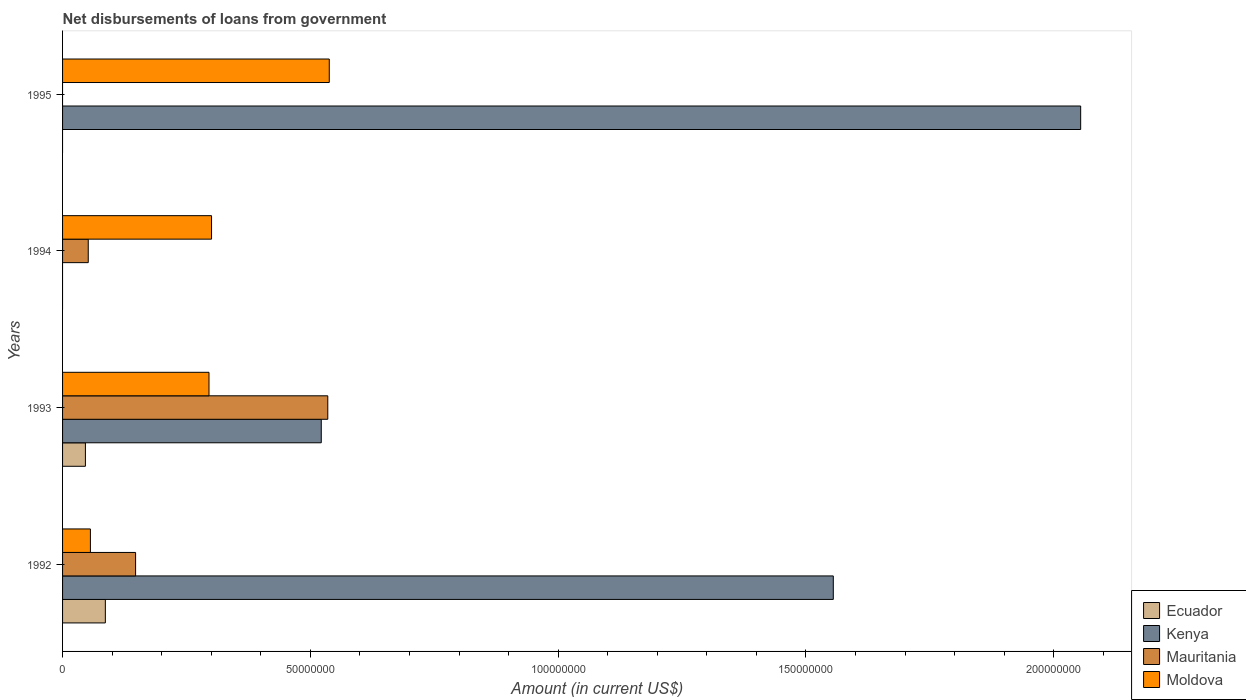Are the number of bars per tick equal to the number of legend labels?
Provide a succinct answer. No. Are the number of bars on each tick of the Y-axis equal?
Provide a succinct answer. No. What is the label of the 1st group of bars from the top?
Provide a succinct answer. 1995. What is the amount of loan disbursed from government in Kenya in 1995?
Give a very brief answer. 2.05e+08. Across all years, what is the maximum amount of loan disbursed from government in Kenya?
Provide a short and direct response. 2.05e+08. In which year was the amount of loan disbursed from government in Ecuador maximum?
Make the answer very short. 1992. What is the total amount of loan disbursed from government in Mauritania in the graph?
Offer a very short reply. 7.34e+07. What is the difference between the amount of loan disbursed from government in Moldova in 1994 and that in 1995?
Provide a short and direct response. -2.38e+07. What is the difference between the amount of loan disbursed from government in Kenya in 1993 and the amount of loan disbursed from government in Mauritania in 1994?
Provide a short and direct response. 4.70e+07. What is the average amount of loan disbursed from government in Kenya per year?
Keep it short and to the point. 1.03e+08. In the year 1993, what is the difference between the amount of loan disbursed from government in Moldova and amount of loan disbursed from government in Mauritania?
Give a very brief answer. -2.40e+07. In how many years, is the amount of loan disbursed from government in Moldova greater than 200000000 US$?
Make the answer very short. 0. What is the ratio of the amount of loan disbursed from government in Moldova in 1994 to that in 1995?
Offer a terse response. 0.56. Is the amount of loan disbursed from government in Kenya in 1993 less than that in 1995?
Make the answer very short. Yes. Is the difference between the amount of loan disbursed from government in Moldova in 1992 and 1994 greater than the difference between the amount of loan disbursed from government in Mauritania in 1992 and 1994?
Your answer should be very brief. No. What is the difference between the highest and the second highest amount of loan disbursed from government in Mauritania?
Make the answer very short. 3.88e+07. What is the difference between the highest and the lowest amount of loan disbursed from government in Moldova?
Provide a succinct answer. 4.82e+07. Is the sum of the amount of loan disbursed from government in Mauritania in 1992 and 1993 greater than the maximum amount of loan disbursed from government in Kenya across all years?
Your answer should be very brief. No. Are all the bars in the graph horizontal?
Offer a very short reply. Yes. How many years are there in the graph?
Give a very brief answer. 4. Are the values on the major ticks of X-axis written in scientific E-notation?
Keep it short and to the point. No. Does the graph contain grids?
Offer a terse response. No. How are the legend labels stacked?
Your response must be concise. Vertical. What is the title of the graph?
Provide a succinct answer. Net disbursements of loans from government. What is the label or title of the Y-axis?
Your response must be concise. Years. What is the Amount (in current US$) in Ecuador in 1992?
Your answer should be very brief. 8.63e+06. What is the Amount (in current US$) of Kenya in 1992?
Offer a terse response. 1.56e+08. What is the Amount (in current US$) of Mauritania in 1992?
Make the answer very short. 1.47e+07. What is the Amount (in current US$) in Moldova in 1992?
Offer a very short reply. 5.62e+06. What is the Amount (in current US$) in Ecuador in 1993?
Your answer should be very brief. 4.61e+06. What is the Amount (in current US$) in Kenya in 1993?
Your answer should be very brief. 5.22e+07. What is the Amount (in current US$) in Mauritania in 1993?
Give a very brief answer. 5.35e+07. What is the Amount (in current US$) of Moldova in 1993?
Your answer should be compact. 2.95e+07. What is the Amount (in current US$) of Ecuador in 1994?
Provide a short and direct response. 0. What is the Amount (in current US$) in Kenya in 1994?
Provide a short and direct response. 0. What is the Amount (in current US$) of Mauritania in 1994?
Your response must be concise. 5.18e+06. What is the Amount (in current US$) in Moldova in 1994?
Make the answer very short. 3.01e+07. What is the Amount (in current US$) in Ecuador in 1995?
Provide a succinct answer. 0. What is the Amount (in current US$) in Kenya in 1995?
Offer a very short reply. 2.05e+08. What is the Amount (in current US$) of Mauritania in 1995?
Provide a succinct answer. 0. What is the Amount (in current US$) of Moldova in 1995?
Provide a short and direct response. 5.38e+07. Across all years, what is the maximum Amount (in current US$) of Ecuador?
Your response must be concise. 8.63e+06. Across all years, what is the maximum Amount (in current US$) of Kenya?
Provide a short and direct response. 2.05e+08. Across all years, what is the maximum Amount (in current US$) in Mauritania?
Make the answer very short. 5.35e+07. Across all years, what is the maximum Amount (in current US$) of Moldova?
Provide a succinct answer. 5.38e+07. Across all years, what is the minimum Amount (in current US$) in Ecuador?
Provide a succinct answer. 0. Across all years, what is the minimum Amount (in current US$) in Kenya?
Offer a terse response. 0. Across all years, what is the minimum Amount (in current US$) of Moldova?
Offer a very short reply. 5.62e+06. What is the total Amount (in current US$) of Ecuador in the graph?
Ensure brevity in your answer.  1.32e+07. What is the total Amount (in current US$) of Kenya in the graph?
Offer a very short reply. 4.13e+08. What is the total Amount (in current US$) of Mauritania in the graph?
Your answer should be compact. 7.34e+07. What is the total Amount (in current US$) in Moldova in the graph?
Give a very brief answer. 1.19e+08. What is the difference between the Amount (in current US$) of Ecuador in 1992 and that in 1993?
Offer a very short reply. 4.02e+06. What is the difference between the Amount (in current US$) in Kenya in 1992 and that in 1993?
Provide a short and direct response. 1.03e+08. What is the difference between the Amount (in current US$) in Mauritania in 1992 and that in 1993?
Provide a short and direct response. -3.88e+07. What is the difference between the Amount (in current US$) in Moldova in 1992 and that in 1993?
Provide a short and direct response. -2.39e+07. What is the difference between the Amount (in current US$) in Mauritania in 1992 and that in 1994?
Offer a terse response. 9.55e+06. What is the difference between the Amount (in current US$) of Moldova in 1992 and that in 1994?
Make the answer very short. -2.44e+07. What is the difference between the Amount (in current US$) in Kenya in 1992 and that in 1995?
Your answer should be compact. -4.99e+07. What is the difference between the Amount (in current US$) in Moldova in 1992 and that in 1995?
Provide a short and direct response. -4.82e+07. What is the difference between the Amount (in current US$) of Mauritania in 1993 and that in 1994?
Offer a very short reply. 4.83e+07. What is the difference between the Amount (in current US$) in Moldova in 1993 and that in 1994?
Ensure brevity in your answer.  -5.13e+05. What is the difference between the Amount (in current US$) of Kenya in 1993 and that in 1995?
Provide a short and direct response. -1.53e+08. What is the difference between the Amount (in current US$) in Moldova in 1993 and that in 1995?
Your response must be concise. -2.43e+07. What is the difference between the Amount (in current US$) of Moldova in 1994 and that in 1995?
Give a very brief answer. -2.38e+07. What is the difference between the Amount (in current US$) in Ecuador in 1992 and the Amount (in current US$) in Kenya in 1993?
Ensure brevity in your answer.  -4.36e+07. What is the difference between the Amount (in current US$) of Ecuador in 1992 and the Amount (in current US$) of Mauritania in 1993?
Provide a short and direct response. -4.49e+07. What is the difference between the Amount (in current US$) in Ecuador in 1992 and the Amount (in current US$) in Moldova in 1993?
Offer a terse response. -2.09e+07. What is the difference between the Amount (in current US$) of Kenya in 1992 and the Amount (in current US$) of Mauritania in 1993?
Keep it short and to the point. 1.02e+08. What is the difference between the Amount (in current US$) of Kenya in 1992 and the Amount (in current US$) of Moldova in 1993?
Your answer should be compact. 1.26e+08. What is the difference between the Amount (in current US$) in Mauritania in 1992 and the Amount (in current US$) in Moldova in 1993?
Offer a very short reply. -1.48e+07. What is the difference between the Amount (in current US$) of Ecuador in 1992 and the Amount (in current US$) of Mauritania in 1994?
Your answer should be compact. 3.45e+06. What is the difference between the Amount (in current US$) of Ecuador in 1992 and the Amount (in current US$) of Moldova in 1994?
Give a very brief answer. -2.14e+07. What is the difference between the Amount (in current US$) of Kenya in 1992 and the Amount (in current US$) of Mauritania in 1994?
Keep it short and to the point. 1.50e+08. What is the difference between the Amount (in current US$) of Kenya in 1992 and the Amount (in current US$) of Moldova in 1994?
Provide a short and direct response. 1.25e+08. What is the difference between the Amount (in current US$) in Mauritania in 1992 and the Amount (in current US$) in Moldova in 1994?
Ensure brevity in your answer.  -1.53e+07. What is the difference between the Amount (in current US$) of Ecuador in 1992 and the Amount (in current US$) of Kenya in 1995?
Your response must be concise. -1.97e+08. What is the difference between the Amount (in current US$) of Ecuador in 1992 and the Amount (in current US$) of Moldova in 1995?
Ensure brevity in your answer.  -4.52e+07. What is the difference between the Amount (in current US$) in Kenya in 1992 and the Amount (in current US$) in Moldova in 1995?
Ensure brevity in your answer.  1.02e+08. What is the difference between the Amount (in current US$) of Mauritania in 1992 and the Amount (in current US$) of Moldova in 1995?
Make the answer very short. -3.91e+07. What is the difference between the Amount (in current US$) in Ecuador in 1993 and the Amount (in current US$) in Mauritania in 1994?
Make the answer very short. -5.72e+05. What is the difference between the Amount (in current US$) in Ecuador in 1993 and the Amount (in current US$) in Moldova in 1994?
Your response must be concise. -2.54e+07. What is the difference between the Amount (in current US$) of Kenya in 1993 and the Amount (in current US$) of Mauritania in 1994?
Provide a succinct answer. 4.70e+07. What is the difference between the Amount (in current US$) of Kenya in 1993 and the Amount (in current US$) of Moldova in 1994?
Offer a terse response. 2.21e+07. What is the difference between the Amount (in current US$) of Mauritania in 1993 and the Amount (in current US$) of Moldova in 1994?
Your answer should be very brief. 2.35e+07. What is the difference between the Amount (in current US$) in Ecuador in 1993 and the Amount (in current US$) in Kenya in 1995?
Offer a terse response. -2.01e+08. What is the difference between the Amount (in current US$) in Ecuador in 1993 and the Amount (in current US$) in Moldova in 1995?
Provide a short and direct response. -4.92e+07. What is the difference between the Amount (in current US$) of Kenya in 1993 and the Amount (in current US$) of Moldova in 1995?
Your answer should be very brief. -1.62e+06. What is the difference between the Amount (in current US$) in Mauritania in 1993 and the Amount (in current US$) in Moldova in 1995?
Your answer should be compact. -3.01e+05. What is the difference between the Amount (in current US$) of Mauritania in 1994 and the Amount (in current US$) of Moldova in 1995?
Provide a succinct answer. -4.86e+07. What is the average Amount (in current US$) in Ecuador per year?
Make the answer very short. 3.31e+06. What is the average Amount (in current US$) in Kenya per year?
Keep it short and to the point. 1.03e+08. What is the average Amount (in current US$) of Mauritania per year?
Keep it short and to the point. 1.84e+07. What is the average Amount (in current US$) of Moldova per year?
Make the answer very short. 2.98e+07. In the year 1992, what is the difference between the Amount (in current US$) of Ecuador and Amount (in current US$) of Kenya?
Keep it short and to the point. -1.47e+08. In the year 1992, what is the difference between the Amount (in current US$) of Ecuador and Amount (in current US$) of Mauritania?
Your response must be concise. -6.10e+06. In the year 1992, what is the difference between the Amount (in current US$) of Ecuador and Amount (in current US$) of Moldova?
Make the answer very short. 3.02e+06. In the year 1992, what is the difference between the Amount (in current US$) of Kenya and Amount (in current US$) of Mauritania?
Provide a short and direct response. 1.41e+08. In the year 1992, what is the difference between the Amount (in current US$) in Kenya and Amount (in current US$) in Moldova?
Keep it short and to the point. 1.50e+08. In the year 1992, what is the difference between the Amount (in current US$) of Mauritania and Amount (in current US$) of Moldova?
Keep it short and to the point. 9.12e+06. In the year 1993, what is the difference between the Amount (in current US$) of Ecuador and Amount (in current US$) of Kenya?
Your response must be concise. -4.76e+07. In the year 1993, what is the difference between the Amount (in current US$) in Ecuador and Amount (in current US$) in Mauritania?
Provide a succinct answer. -4.89e+07. In the year 1993, what is the difference between the Amount (in current US$) in Ecuador and Amount (in current US$) in Moldova?
Give a very brief answer. -2.49e+07. In the year 1993, what is the difference between the Amount (in current US$) in Kenya and Amount (in current US$) in Mauritania?
Provide a short and direct response. -1.32e+06. In the year 1993, what is the difference between the Amount (in current US$) in Kenya and Amount (in current US$) in Moldova?
Your answer should be very brief. 2.27e+07. In the year 1993, what is the difference between the Amount (in current US$) of Mauritania and Amount (in current US$) of Moldova?
Ensure brevity in your answer.  2.40e+07. In the year 1994, what is the difference between the Amount (in current US$) of Mauritania and Amount (in current US$) of Moldova?
Offer a terse response. -2.49e+07. In the year 1995, what is the difference between the Amount (in current US$) in Kenya and Amount (in current US$) in Moldova?
Give a very brief answer. 1.52e+08. What is the ratio of the Amount (in current US$) in Ecuador in 1992 to that in 1993?
Ensure brevity in your answer.  1.87. What is the ratio of the Amount (in current US$) of Kenya in 1992 to that in 1993?
Your answer should be compact. 2.98. What is the ratio of the Amount (in current US$) in Mauritania in 1992 to that in 1993?
Your answer should be compact. 0.28. What is the ratio of the Amount (in current US$) in Moldova in 1992 to that in 1993?
Provide a short and direct response. 0.19. What is the ratio of the Amount (in current US$) of Mauritania in 1992 to that in 1994?
Offer a terse response. 2.84. What is the ratio of the Amount (in current US$) in Moldova in 1992 to that in 1994?
Your response must be concise. 0.19. What is the ratio of the Amount (in current US$) of Kenya in 1992 to that in 1995?
Your answer should be very brief. 0.76. What is the ratio of the Amount (in current US$) of Moldova in 1992 to that in 1995?
Provide a succinct answer. 0.1. What is the ratio of the Amount (in current US$) in Mauritania in 1993 to that in 1994?
Give a very brief answer. 10.33. What is the ratio of the Amount (in current US$) of Moldova in 1993 to that in 1994?
Keep it short and to the point. 0.98. What is the ratio of the Amount (in current US$) in Kenya in 1993 to that in 1995?
Your answer should be compact. 0.25. What is the ratio of the Amount (in current US$) of Moldova in 1993 to that in 1995?
Keep it short and to the point. 0.55. What is the ratio of the Amount (in current US$) in Moldova in 1994 to that in 1995?
Ensure brevity in your answer.  0.56. What is the difference between the highest and the second highest Amount (in current US$) in Kenya?
Keep it short and to the point. 4.99e+07. What is the difference between the highest and the second highest Amount (in current US$) of Mauritania?
Keep it short and to the point. 3.88e+07. What is the difference between the highest and the second highest Amount (in current US$) in Moldova?
Provide a succinct answer. 2.38e+07. What is the difference between the highest and the lowest Amount (in current US$) in Ecuador?
Your answer should be very brief. 8.63e+06. What is the difference between the highest and the lowest Amount (in current US$) in Kenya?
Provide a short and direct response. 2.05e+08. What is the difference between the highest and the lowest Amount (in current US$) of Mauritania?
Your answer should be compact. 5.35e+07. What is the difference between the highest and the lowest Amount (in current US$) in Moldova?
Provide a short and direct response. 4.82e+07. 